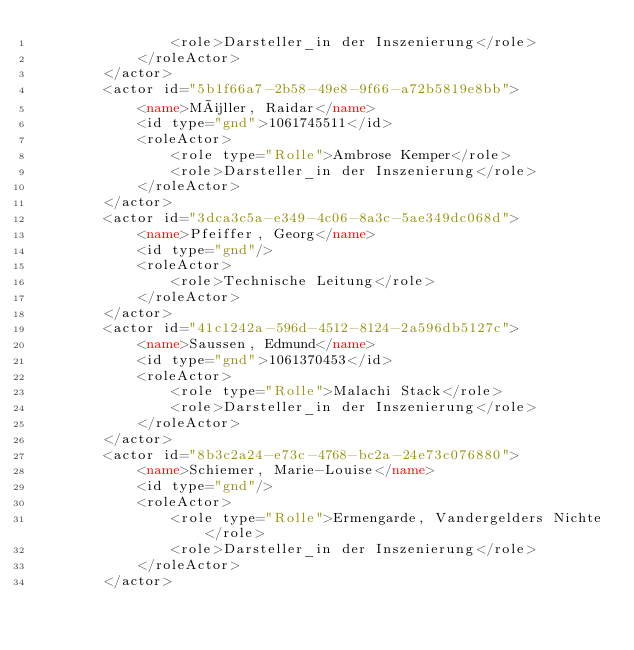<code> <loc_0><loc_0><loc_500><loc_500><_XML_>                <role>Darsteller_in der Inszenierung</role>
            </roleActor>
        </actor>
        <actor id="5b1f66a7-2b58-49e8-9f66-a72b5819e8bb">
            <name>Müller, Raidar</name>
            <id type="gnd">1061745511</id>
            <roleActor>
                <role type="Rolle">Ambrose Kemper</role>
                <role>Darsteller_in der Inszenierung</role>
            </roleActor>
        </actor>
        <actor id="3dca3c5a-e349-4c06-8a3c-5ae349dc068d">
            <name>Pfeiffer, Georg</name>
            <id type="gnd"/>
            <roleActor>
                <role>Technische Leitung</role>
            </roleActor>
        </actor>
        <actor id="41c1242a-596d-4512-8124-2a596db5127c">
            <name>Saussen, Edmund</name>
            <id type="gnd">1061370453</id>
            <roleActor>
                <role type="Rolle">Malachi Stack</role>
                <role>Darsteller_in der Inszenierung</role>
            </roleActor>
        </actor>
        <actor id="8b3c2a24-e73c-4768-bc2a-24e73c076880">
            <name>Schiemer, Marie-Louise</name>
            <id type="gnd"/>
            <roleActor>
                <role type="Rolle">Ermengarde, Vandergelders Nichte</role>
                <role>Darsteller_in der Inszenierung</role>
            </roleActor>
        </actor></code> 